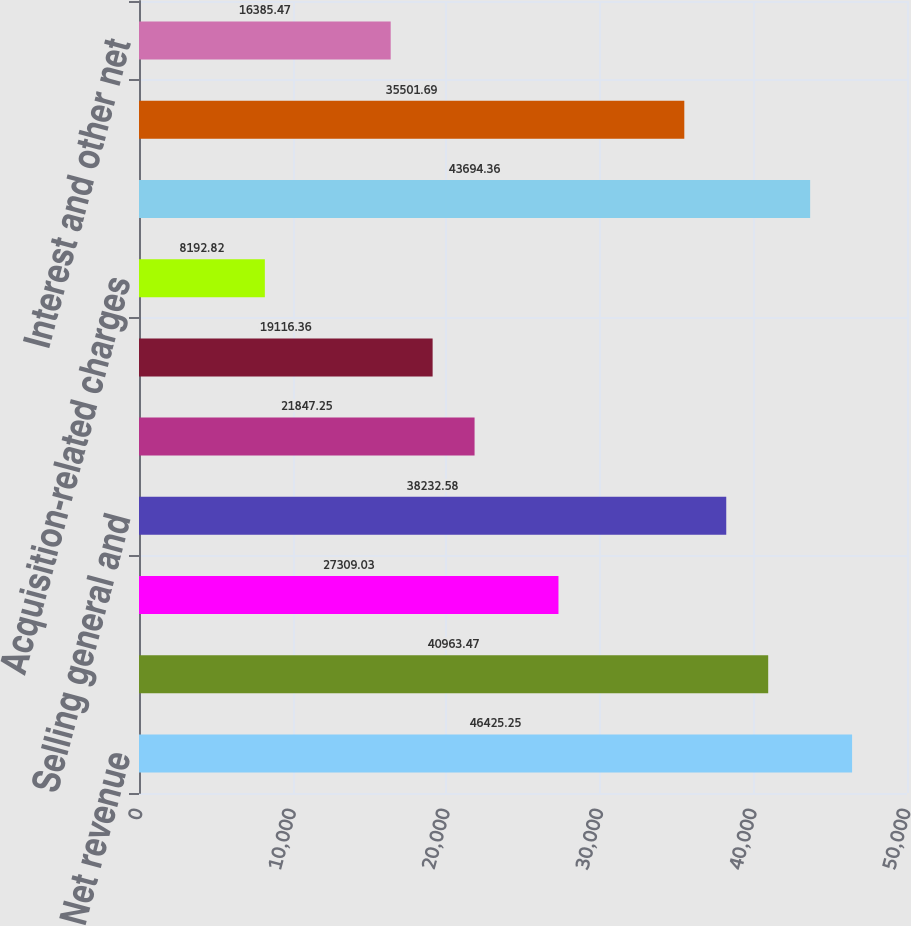Convert chart. <chart><loc_0><loc_0><loc_500><loc_500><bar_chart><fcel>Net revenue<fcel>Cost of sales (1)<fcel>Research and development<fcel>Selling general and<fcel>Amortization of intangible<fcel>Restructuring charges<fcel>Acquisition-related charges<fcel>Total costs and expenses<fcel>Earnings from operations<fcel>Interest and other net<nl><fcel>46425.2<fcel>40963.5<fcel>27309<fcel>38232.6<fcel>21847.2<fcel>19116.4<fcel>8192.82<fcel>43694.4<fcel>35501.7<fcel>16385.5<nl></chart> 